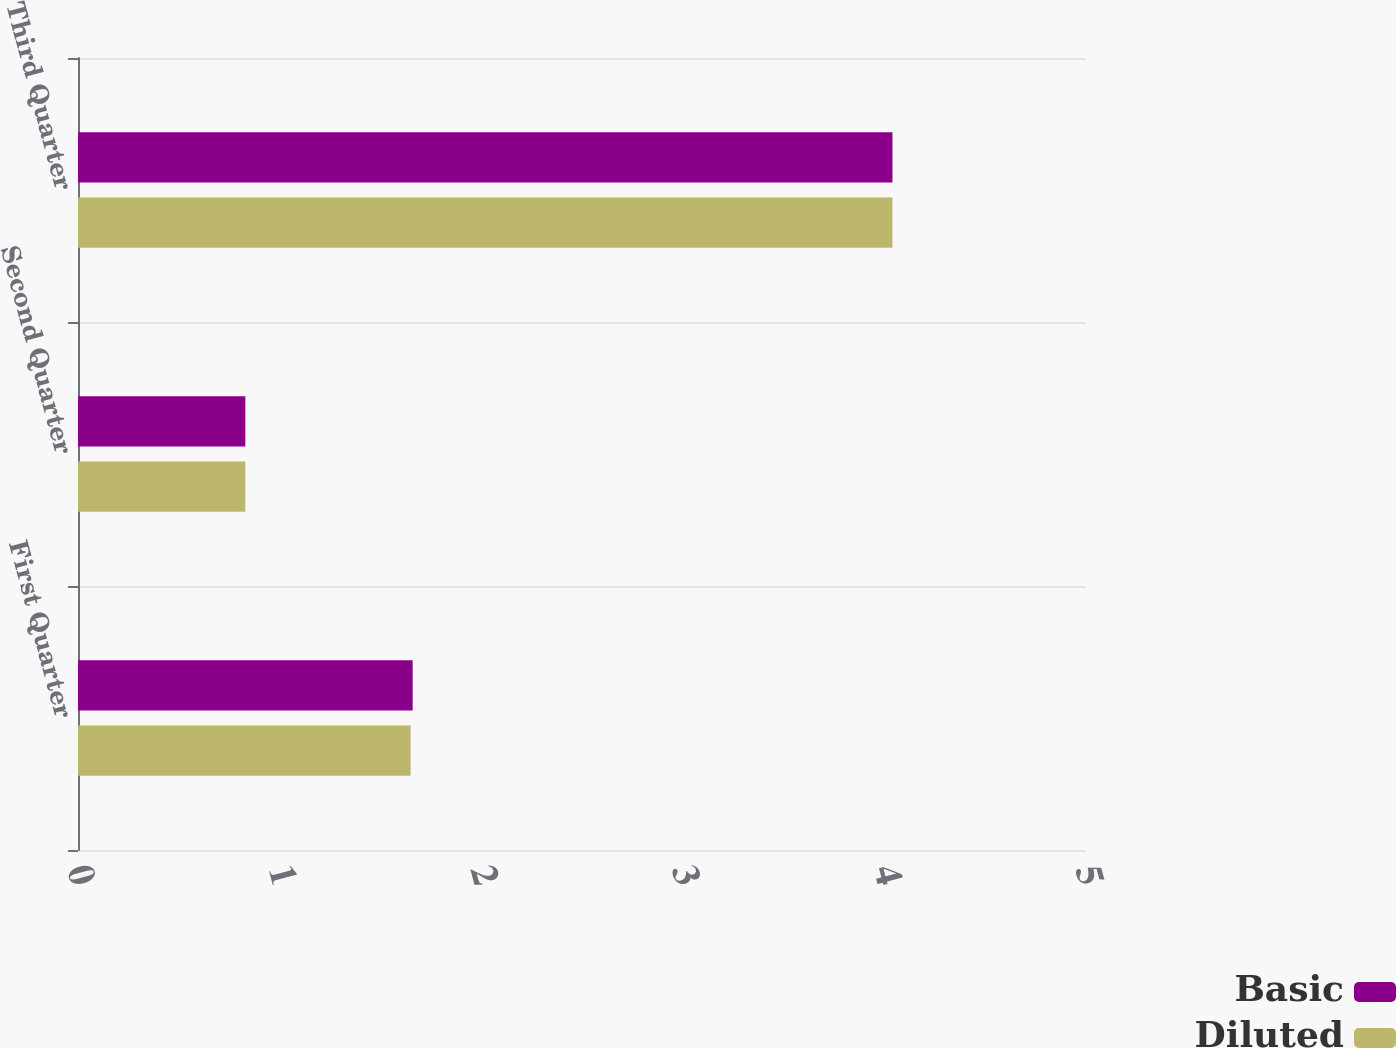Convert chart. <chart><loc_0><loc_0><loc_500><loc_500><stacked_bar_chart><ecel><fcel>First Quarter<fcel>Second Quarter<fcel>Third Quarter<nl><fcel>Basic<fcel>1.66<fcel>0.83<fcel>4.04<nl><fcel>Diluted<fcel>1.65<fcel>0.83<fcel>4.04<nl></chart> 